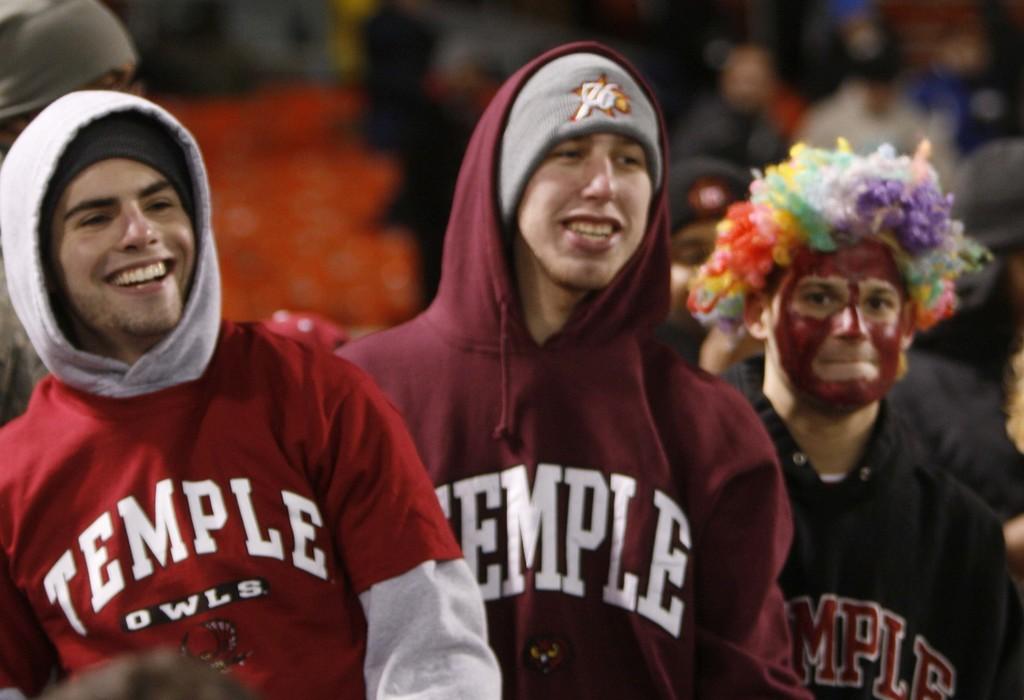What is the bird of prey the temple sports team uses as a mascot?
Your answer should be compact. Owl. What is the name of the school the people are cheering for?
Make the answer very short. Temple. 